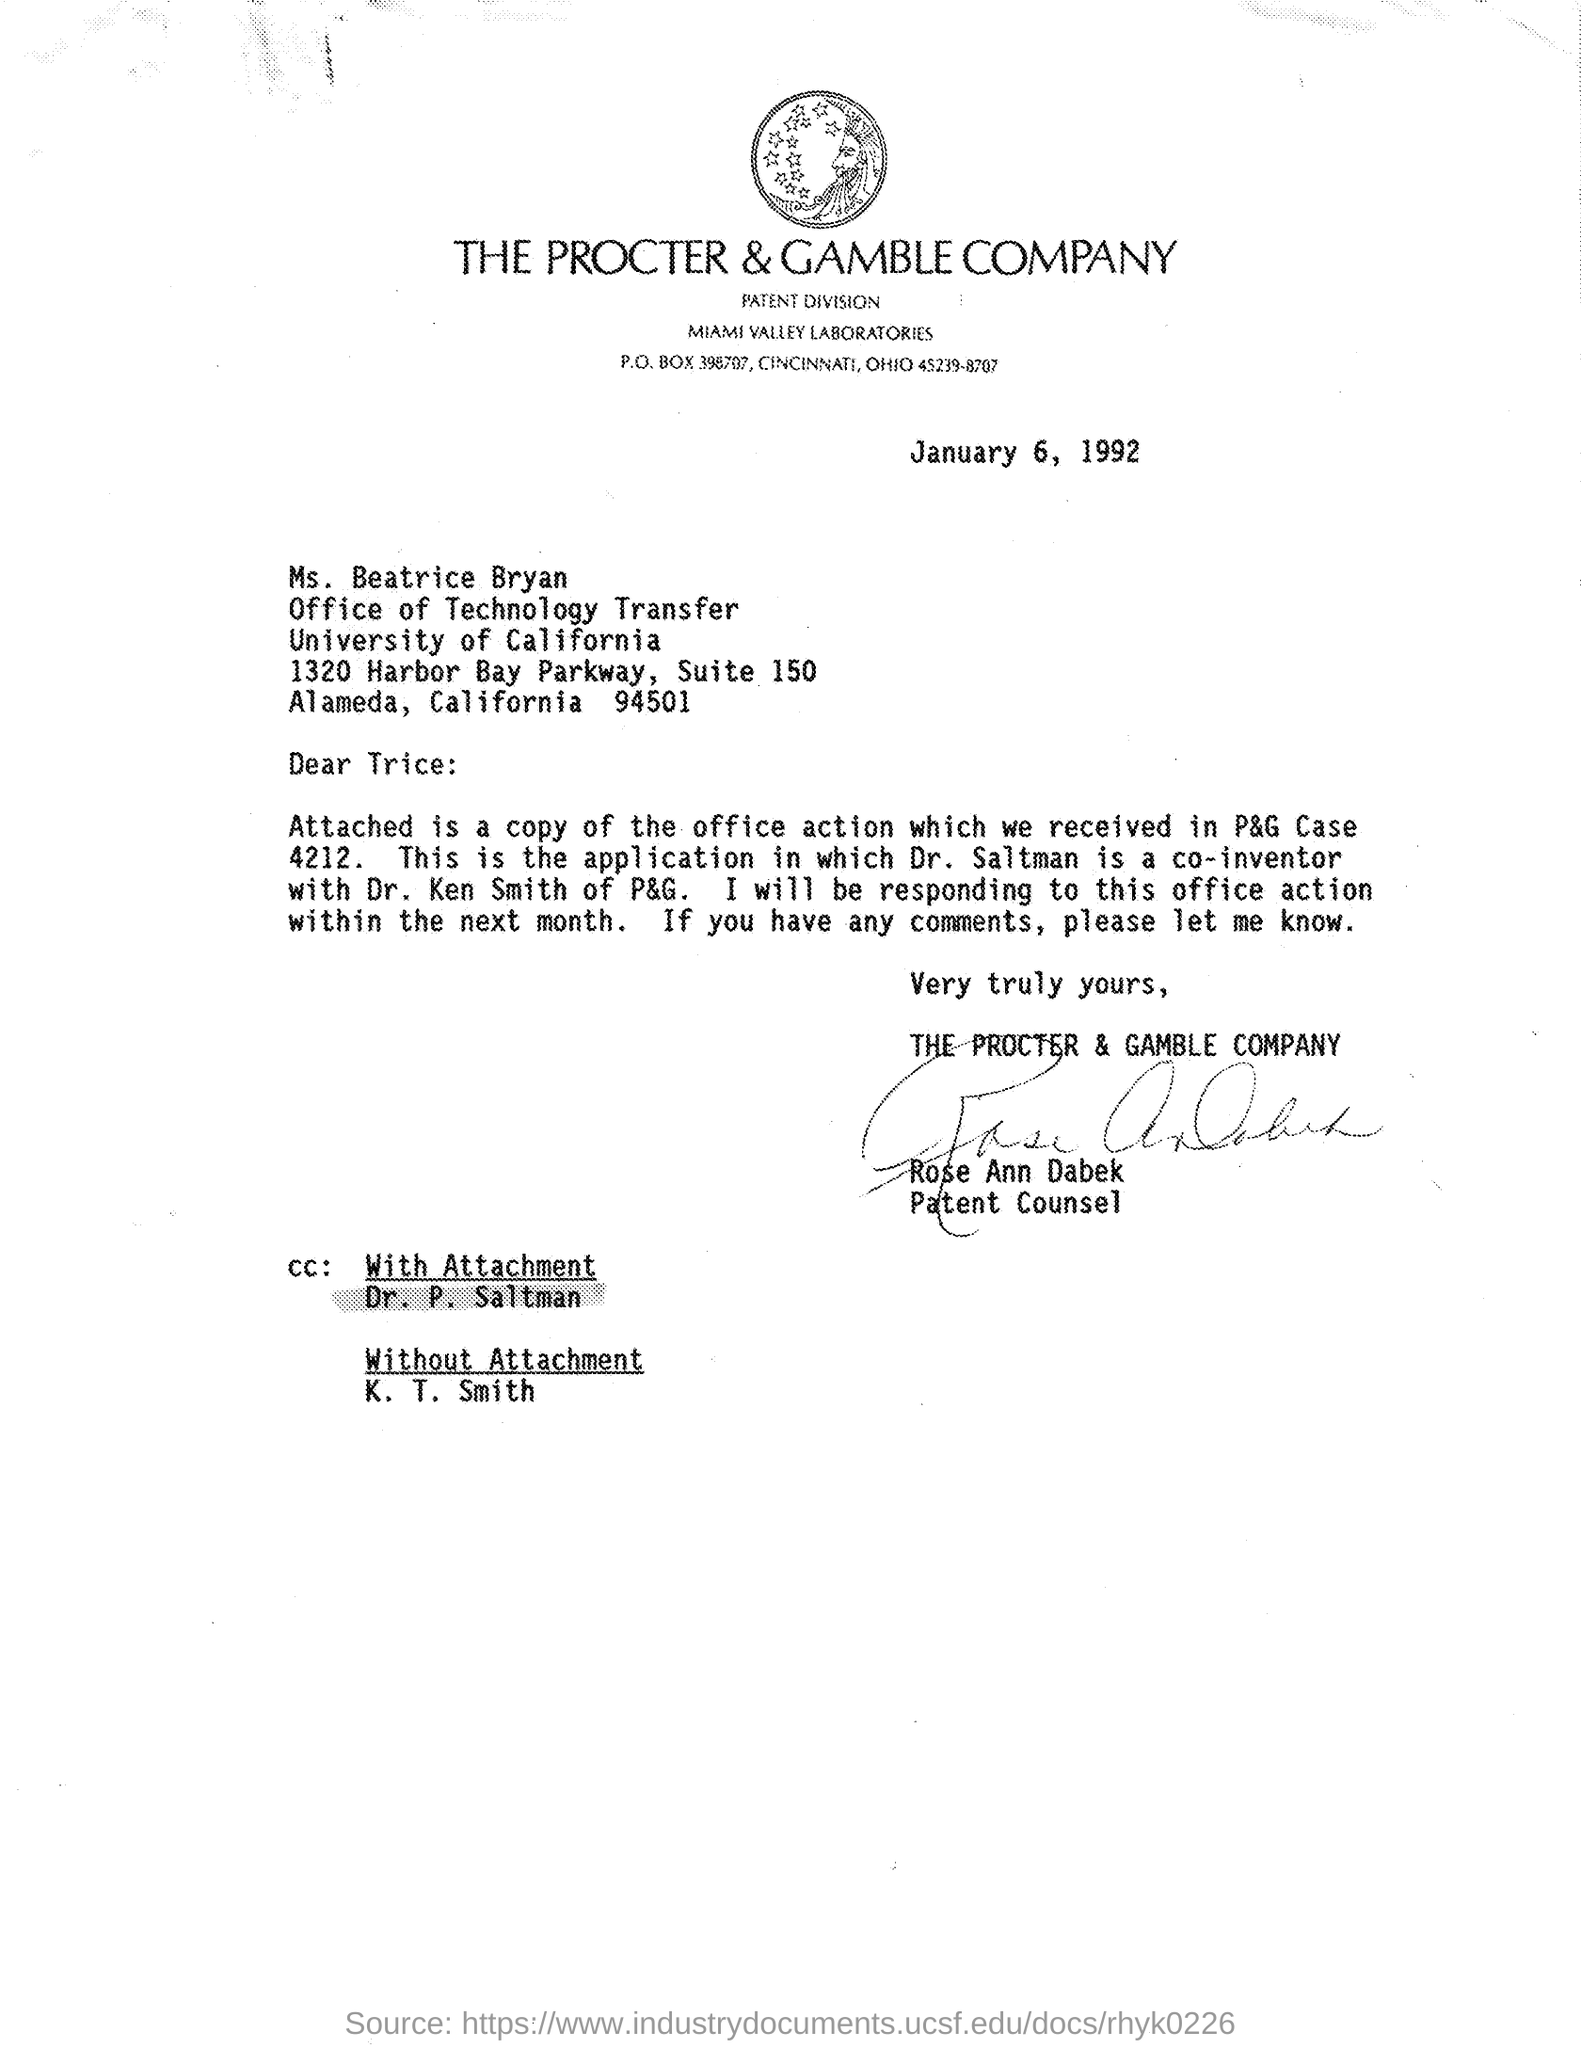What is the date mentioned ?
Give a very brief answer. January 6, 1992. Who is mentioned in the cc with attachment
Offer a very short reply. Dr. P. Saltman. Who is mentioned in the cc without  attachment
Offer a terse response. K. T. Smith. To whom this letter is written
Offer a very short reply. Trice. 